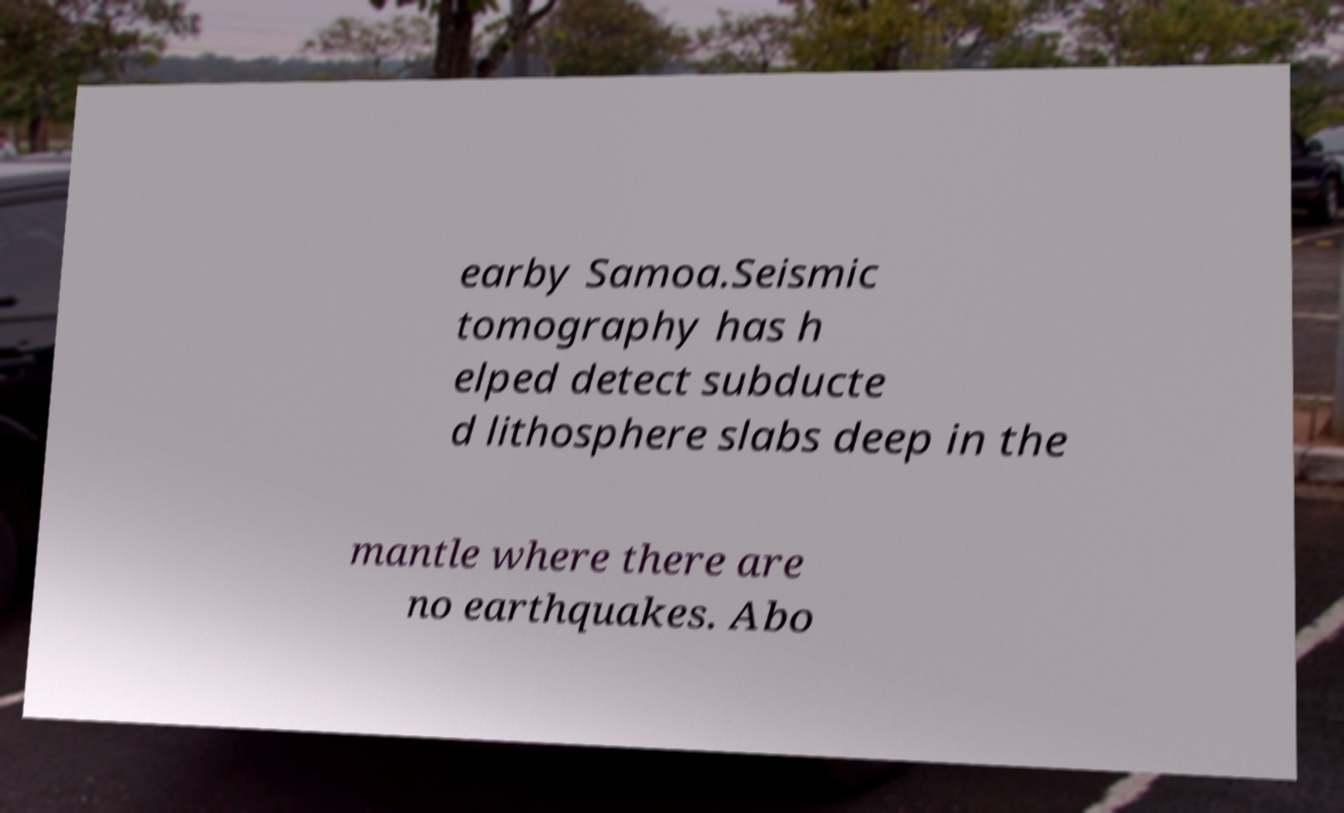For documentation purposes, I need the text within this image transcribed. Could you provide that? earby Samoa.Seismic tomography has h elped detect subducte d lithosphere slabs deep in the mantle where there are no earthquakes. Abo 